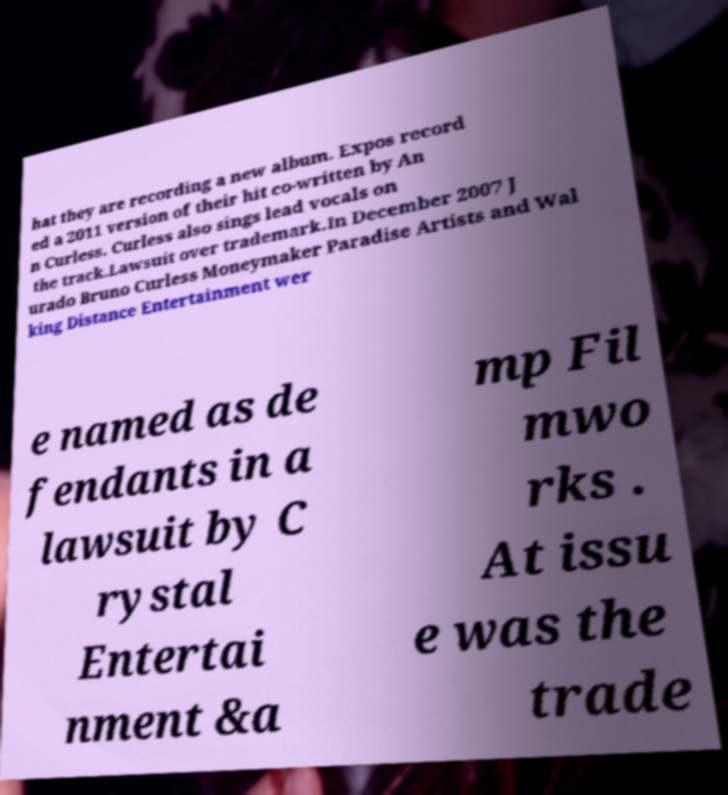For documentation purposes, I need the text within this image transcribed. Could you provide that? hat they are recording a new album. Expos record ed a 2011 version of their hit co-written by An n Curless. Curless also sings lead vocals on the track.Lawsuit over trademark.In December 2007 J urado Bruno Curless Moneymaker Paradise Artists and Wal king Distance Entertainment wer e named as de fendants in a lawsuit by C rystal Entertai nment &a mp Fil mwo rks . At issu e was the trade 